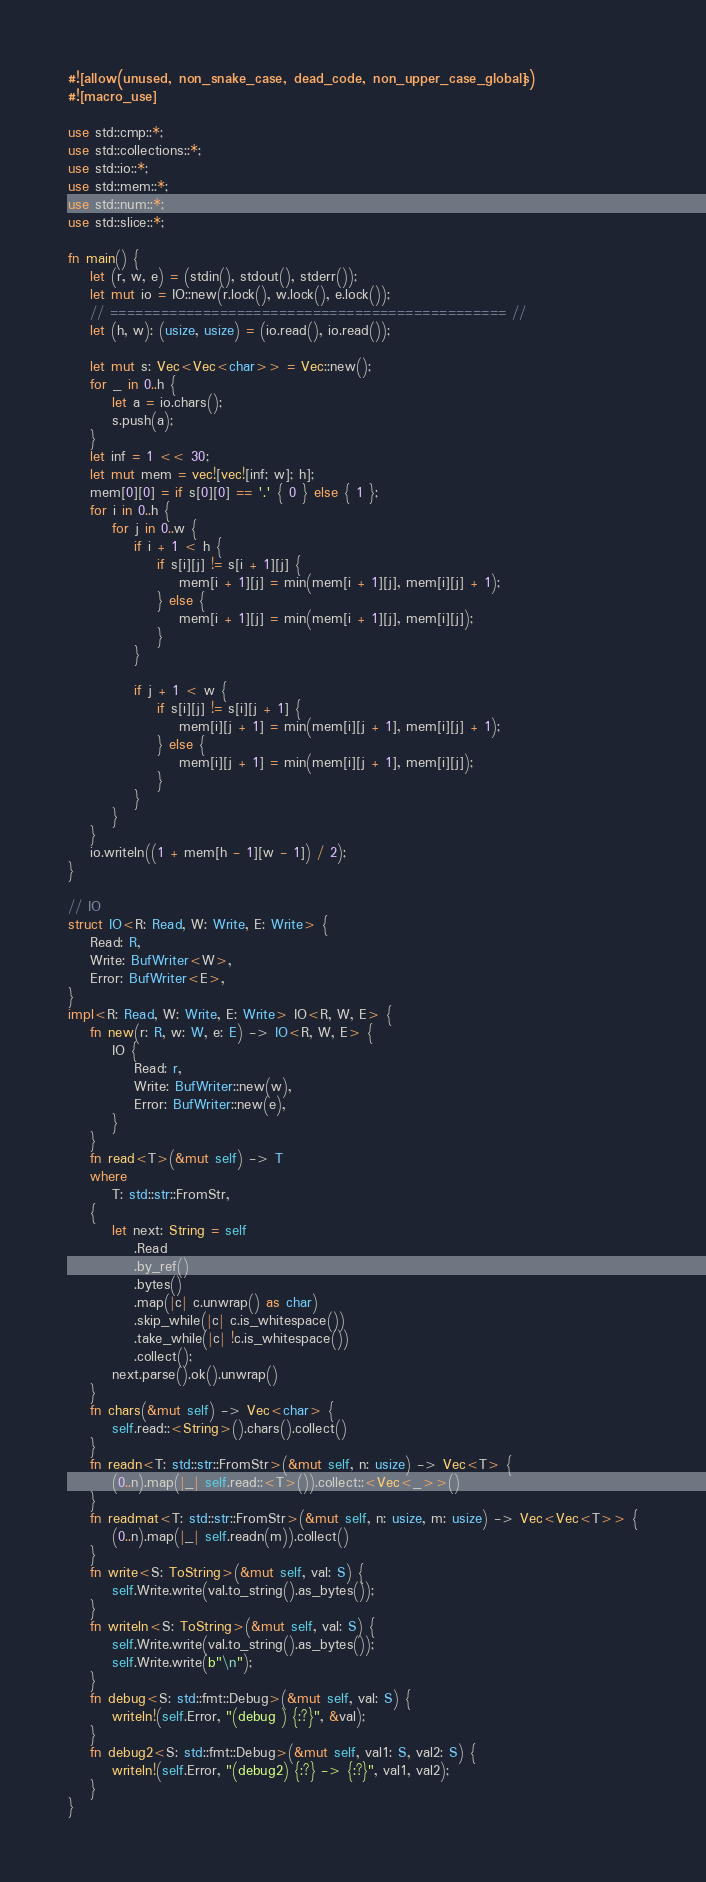Convert code to text. <code><loc_0><loc_0><loc_500><loc_500><_Rust_>#![allow(unused, non_snake_case, dead_code, non_upper_case_globals)]
#![macro_use]

use std::cmp::*;
use std::collections::*;
use std::io::*;
use std::mem::*;
use std::num::*;
use std::slice::*;

fn main() {
    let (r, w, e) = (stdin(), stdout(), stderr());
    let mut io = IO::new(r.lock(), w.lock(), e.lock());
    // =============================================== //
    let (h, w): (usize, usize) = (io.read(), io.read());

    let mut s: Vec<Vec<char>> = Vec::new();
    for _ in 0..h {
        let a = io.chars();
        s.push(a);
    }
    let inf = 1 << 30;
    let mut mem = vec![vec![inf; w]; h];
    mem[0][0] = if s[0][0] == '.' { 0 } else { 1 };
    for i in 0..h {
        for j in 0..w {
            if i + 1 < h {
                if s[i][j] != s[i + 1][j] {
                    mem[i + 1][j] = min(mem[i + 1][j], mem[i][j] + 1);
                } else {
                    mem[i + 1][j] = min(mem[i + 1][j], mem[i][j]);
                }
            }

            if j + 1 < w {
                if s[i][j] != s[i][j + 1] {
                    mem[i][j + 1] = min(mem[i][j + 1], mem[i][j] + 1);
                } else {
                    mem[i][j + 1] = min(mem[i][j + 1], mem[i][j]);
                }
            }
        }
    }
    io.writeln((1 + mem[h - 1][w - 1]) / 2);
}

// IO
struct IO<R: Read, W: Write, E: Write> {
    Read: R,
    Write: BufWriter<W>,
    Error: BufWriter<E>,
}
impl<R: Read, W: Write, E: Write> IO<R, W, E> {
    fn new(r: R, w: W, e: E) -> IO<R, W, E> {
        IO {
            Read: r,
            Write: BufWriter::new(w),
            Error: BufWriter::new(e),
        }
    }
    fn read<T>(&mut self) -> T
    where
        T: std::str::FromStr,
    {
        let next: String = self
            .Read
            .by_ref()
            .bytes()
            .map(|c| c.unwrap() as char)
            .skip_while(|c| c.is_whitespace())
            .take_while(|c| !c.is_whitespace())
            .collect();
        next.parse().ok().unwrap()
    }
    fn chars(&mut self) -> Vec<char> {
        self.read::<String>().chars().collect()
    }
    fn readn<T: std::str::FromStr>(&mut self, n: usize) -> Vec<T> {
        (0..n).map(|_| self.read::<T>()).collect::<Vec<_>>()
    }
    fn readmat<T: std::str::FromStr>(&mut self, n: usize, m: usize) -> Vec<Vec<T>> {
        (0..n).map(|_| self.readn(m)).collect()
    }
    fn write<S: ToString>(&mut self, val: S) {
        self.Write.write(val.to_string().as_bytes());
    }
    fn writeln<S: ToString>(&mut self, val: S) {
        self.Write.write(val.to_string().as_bytes());
        self.Write.write(b"\n");
    }
    fn debug<S: std::fmt::Debug>(&mut self, val: S) {
        writeln!(self.Error, "(debug ) {:?}", &val);
    }
    fn debug2<S: std::fmt::Debug>(&mut self, val1: S, val2: S) {
        writeln!(self.Error, "(debug2) {:?} -> {:?}", val1, val2);
    }
}
</code> 